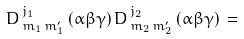<formula> <loc_0><loc_0><loc_500><loc_500>D ^ { \, j _ { 1 } } _ { \, m _ { 1 } \, m ^ { \prime } _ { 1 } } \, ( \alpha \beta \gamma ) \, D ^ { \, j _ { 2 } } _ { \, m _ { 2 } \, m ^ { \prime } _ { 2 } } \, ( \alpha \beta \gamma ) \, =</formula> 